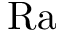<formula> <loc_0><loc_0><loc_500><loc_500>R a</formula> 